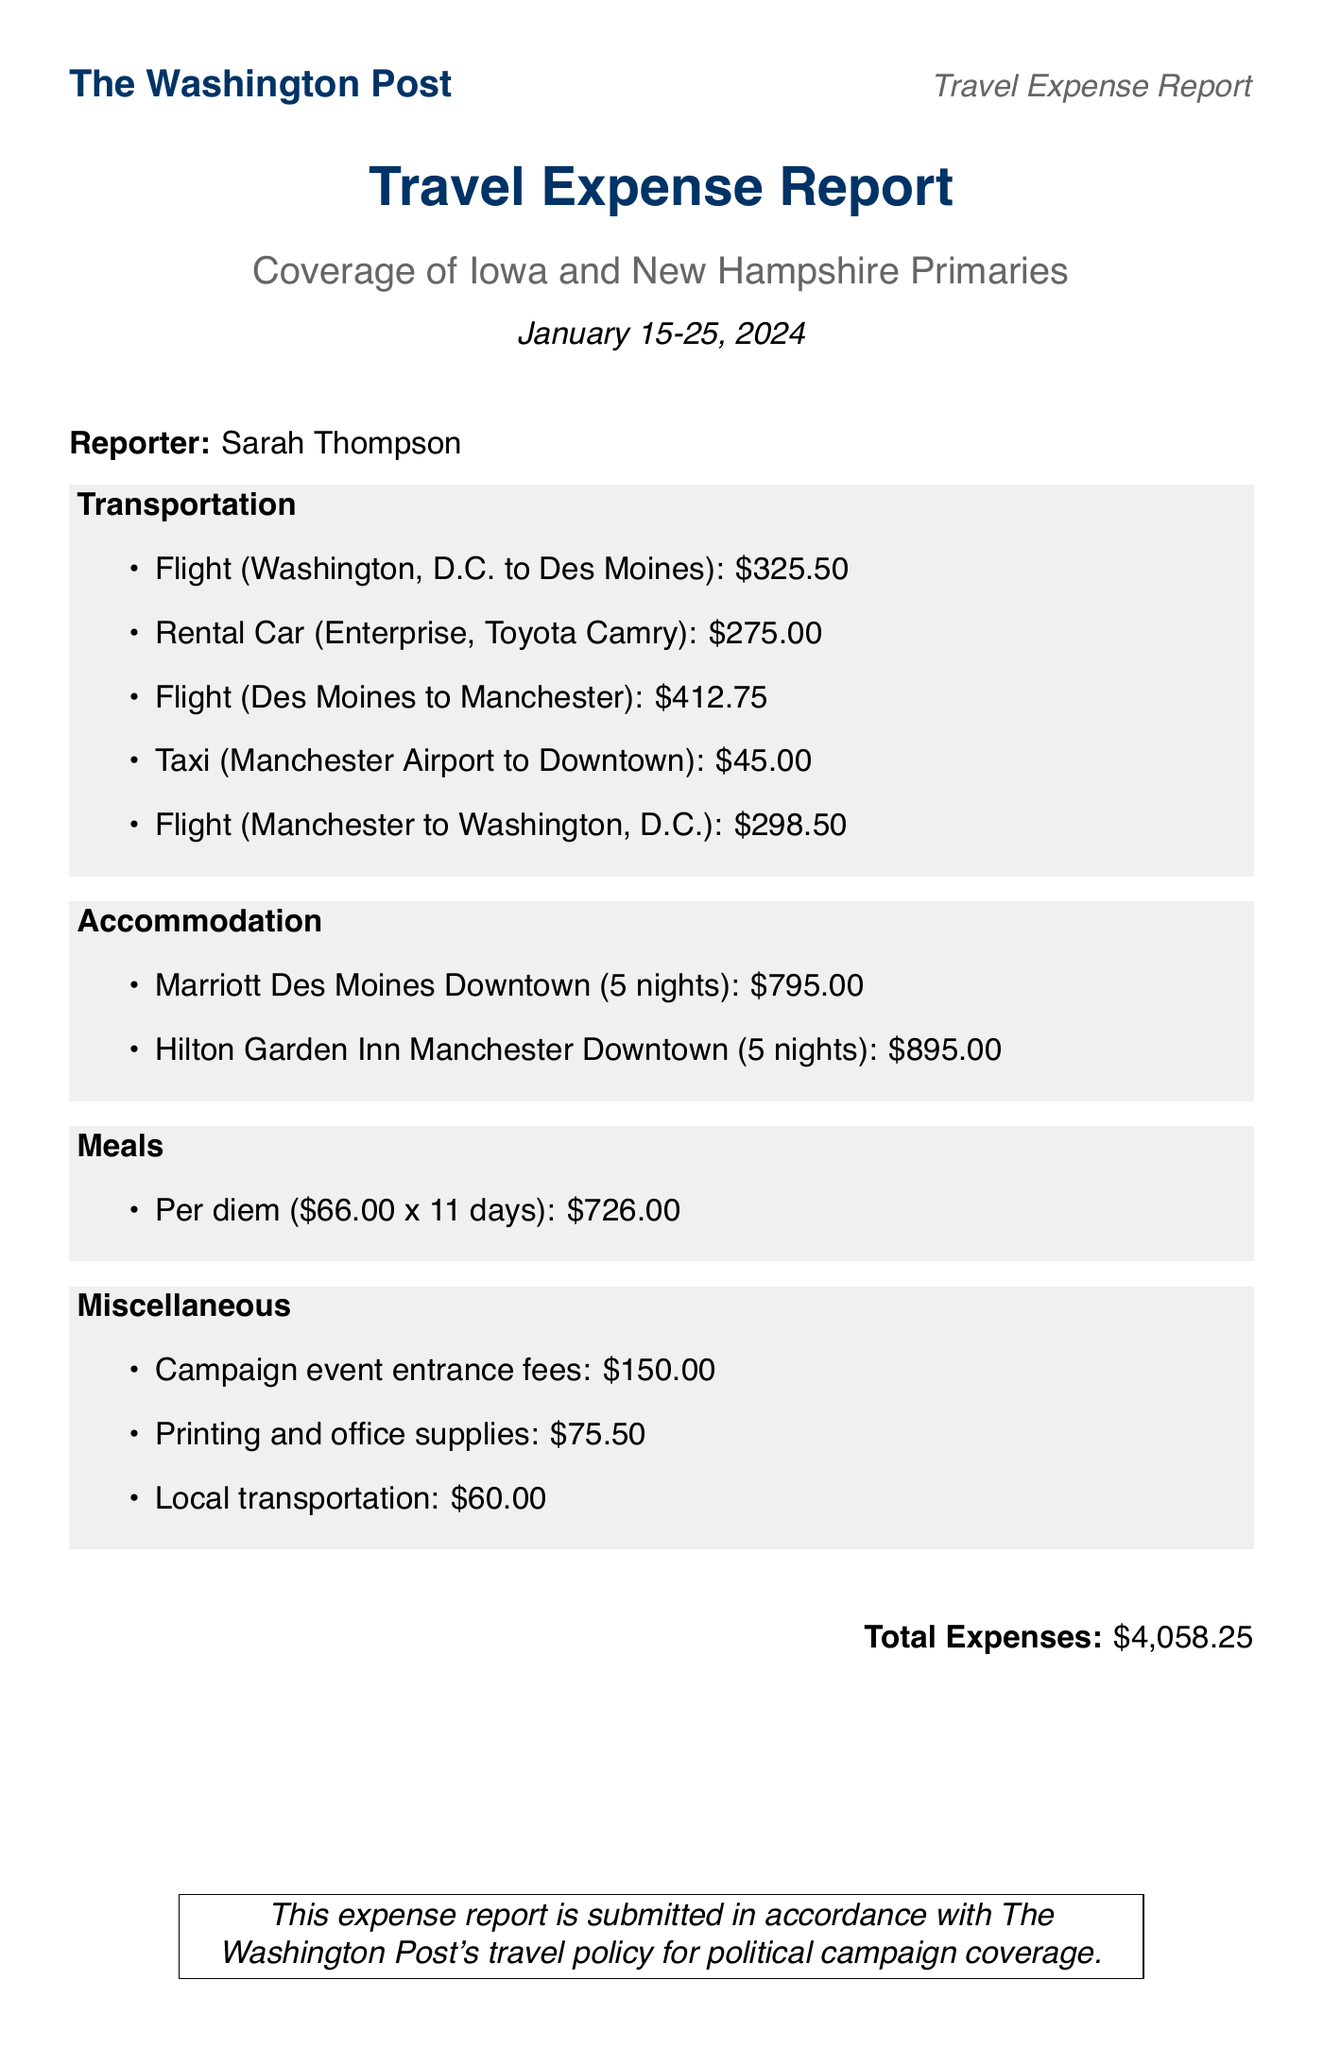what is the name of the reporter? The document specifies the reporter's name as Sarah Thompson.
Answer: Sarah Thompson what is the total cost for meals? The total cost for meals is calculated based on the per diem rate multiplied by the number of days. It is shown in the document as $726.00.
Answer: $726.00 how many nights did the reporter stay in Des Moines? The document lists the accommodation in Des Moines as 5 nights at the Marriott Des Moines Downtown.
Answer: 5 what type of vehicle was rented? The rental vehicle specified in the document is a Toyota Camry from Enterprise.
Answer: Toyota Camry what was the cost of the flight from Des Moines to Manchester? The document lists the cost of the flight from Des Moines to Manchester as $412.75.
Answer: $412.75 how much were the campaign event entrance fees? The fees for campaign events, as specified in the miscellaneous section, are listed as $150.00.
Answer: $150.00 what is the total amount of transportation costs? The transportation costs have been listed as separate entries with their individual amounts, which sum up to $1,356.25.
Answer: $1,356.25 what is the nightly rate for the hotel in Manchester? The document states the nightly rate for the Hilton Garden Inn in Manchester is $179.00.
Answer: $179.00 how many days was the assignment for? The assignment dates in the document indicate it was from January 15 to January 25, 2024, which totals 11 days.
Answer: 11 days 